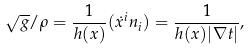Convert formula to latex. <formula><loc_0><loc_0><loc_500><loc_500>\sqrt { g } / \rho = \frac { 1 } { h ( x ) } ( \dot { x } ^ { i } n _ { i } ) = \frac { 1 } { h ( x ) | \nabla t | } ,</formula> 